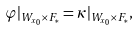Convert formula to latex. <formula><loc_0><loc_0><loc_500><loc_500>\varphi | _ { W _ { x _ { 0 } } \times F _ { * } } = \kappa | _ { W _ { x _ { 0 } } \times F _ { * } } ,</formula> 